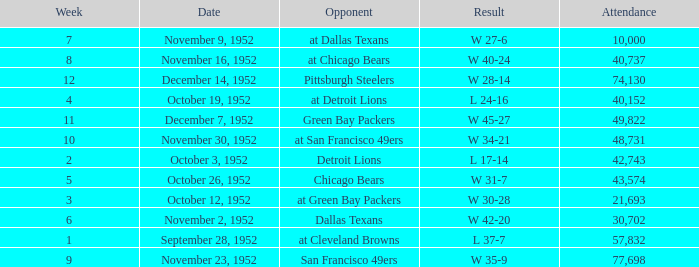Would you be able to parse every entry in this table? {'header': ['Week', 'Date', 'Opponent', 'Result', 'Attendance'], 'rows': [['7', 'November 9, 1952', 'at Dallas Texans', 'W 27-6', '10,000'], ['8', 'November 16, 1952', 'at Chicago Bears', 'W 40-24', '40,737'], ['12', 'December 14, 1952', 'Pittsburgh Steelers', 'W 28-14', '74,130'], ['4', 'October 19, 1952', 'at Detroit Lions', 'L 24-16', '40,152'], ['11', 'December 7, 1952', 'Green Bay Packers', 'W 45-27', '49,822'], ['10', 'November 30, 1952', 'at San Francisco 49ers', 'W 34-21', '48,731'], ['2', 'October 3, 1952', 'Detroit Lions', 'L 17-14', '42,743'], ['5', 'October 26, 1952', 'Chicago Bears', 'W 31-7', '43,574'], ['3', 'October 12, 1952', 'at Green Bay Packers', 'W 30-28', '21,693'], ['6', 'November 2, 1952', 'Dallas Texans', 'W 42-20', '30,702'], ['1', 'September 28, 1952', 'at Cleveland Browns', 'L 37-7', '57,832'], ['9', 'November 23, 1952', 'San Francisco 49ers', 'W 35-9', '77,698']]} When is the last week that has a result of a w 34-21? 10.0. 